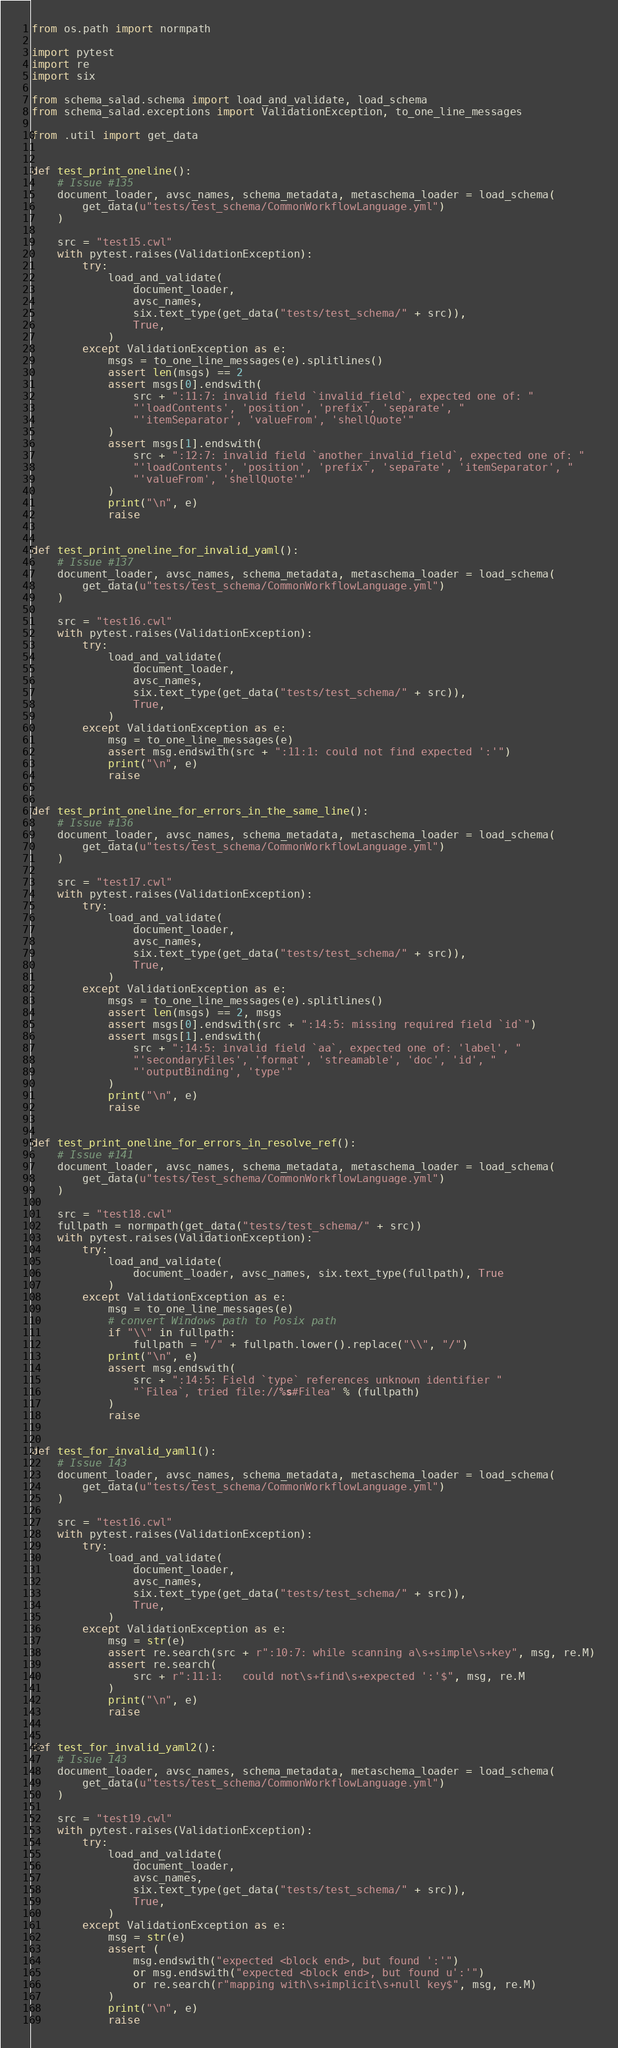<code> <loc_0><loc_0><loc_500><loc_500><_Python_>from os.path import normpath

import pytest
import re
import six

from schema_salad.schema import load_and_validate, load_schema
from schema_salad.exceptions import ValidationException, to_one_line_messages

from .util import get_data


def test_print_oneline():
    # Issue #135
    document_loader, avsc_names, schema_metadata, metaschema_loader = load_schema(
        get_data(u"tests/test_schema/CommonWorkflowLanguage.yml")
    )

    src = "test15.cwl"
    with pytest.raises(ValidationException):
        try:
            load_and_validate(
                document_loader,
                avsc_names,
                six.text_type(get_data("tests/test_schema/" + src)),
                True,
            )
        except ValidationException as e:
            msgs = to_one_line_messages(e).splitlines()
            assert len(msgs) == 2
            assert msgs[0].endswith(
                src + ":11:7: invalid field `invalid_field`, expected one of: "
                "'loadContents', 'position', 'prefix', 'separate', "
                "'itemSeparator', 'valueFrom', 'shellQuote'"
            )
            assert msgs[1].endswith(
                src + ":12:7: invalid field `another_invalid_field`, expected one of: "
                "'loadContents', 'position', 'prefix', 'separate', 'itemSeparator', "
                "'valueFrom', 'shellQuote'"
            )
            print("\n", e)
            raise


def test_print_oneline_for_invalid_yaml():
    # Issue #137
    document_loader, avsc_names, schema_metadata, metaschema_loader = load_schema(
        get_data(u"tests/test_schema/CommonWorkflowLanguage.yml")
    )

    src = "test16.cwl"
    with pytest.raises(ValidationException):
        try:
            load_and_validate(
                document_loader,
                avsc_names,
                six.text_type(get_data("tests/test_schema/" + src)),
                True,
            )
        except ValidationException as e:
            msg = to_one_line_messages(e)
            assert msg.endswith(src + ":11:1: could not find expected ':'")
            print("\n", e)
            raise


def test_print_oneline_for_errors_in_the_same_line():
    # Issue #136
    document_loader, avsc_names, schema_metadata, metaschema_loader = load_schema(
        get_data(u"tests/test_schema/CommonWorkflowLanguage.yml")
    )

    src = "test17.cwl"
    with pytest.raises(ValidationException):
        try:
            load_and_validate(
                document_loader,
                avsc_names,
                six.text_type(get_data("tests/test_schema/" + src)),
                True,
            )
        except ValidationException as e:
            msgs = to_one_line_messages(e).splitlines()
            assert len(msgs) == 2, msgs
            assert msgs[0].endswith(src + ":14:5: missing required field `id`")
            assert msgs[1].endswith(
                src + ":14:5: invalid field `aa`, expected one of: 'label', "
                "'secondaryFiles', 'format', 'streamable', 'doc', 'id', "
                "'outputBinding', 'type'"
            )
            print("\n", e)
            raise


def test_print_oneline_for_errors_in_resolve_ref():
    # Issue #141
    document_loader, avsc_names, schema_metadata, metaschema_loader = load_schema(
        get_data(u"tests/test_schema/CommonWorkflowLanguage.yml")
    )

    src = "test18.cwl"
    fullpath = normpath(get_data("tests/test_schema/" + src))
    with pytest.raises(ValidationException):
        try:
            load_and_validate(
                document_loader, avsc_names, six.text_type(fullpath), True
            )
        except ValidationException as e:
            msg = to_one_line_messages(e)
            # convert Windows path to Posix path
            if "\\" in fullpath:
                fullpath = "/" + fullpath.lower().replace("\\", "/")
            print("\n", e)
            assert msg.endswith(
                src + ":14:5: Field `type` references unknown identifier "
                "`Filea`, tried file://%s#Filea" % (fullpath)
            )
            raise


def test_for_invalid_yaml1():
    # Issue 143
    document_loader, avsc_names, schema_metadata, metaschema_loader = load_schema(
        get_data(u"tests/test_schema/CommonWorkflowLanguage.yml")
    )

    src = "test16.cwl"
    with pytest.raises(ValidationException):
        try:
            load_and_validate(
                document_loader,
                avsc_names,
                six.text_type(get_data("tests/test_schema/" + src)),
                True,
            )
        except ValidationException as e:
            msg = str(e)
            assert re.search(src + r":10:7: while scanning a\s+simple\s+key", msg, re.M)
            assert re.search(
                src + r":11:1:   could not\s+find\s+expected ':'$", msg, re.M
            )
            print("\n", e)
            raise


def test_for_invalid_yaml2():
    # Issue 143
    document_loader, avsc_names, schema_metadata, metaschema_loader = load_schema(
        get_data(u"tests/test_schema/CommonWorkflowLanguage.yml")
    )

    src = "test19.cwl"
    with pytest.raises(ValidationException):
        try:
            load_and_validate(
                document_loader,
                avsc_names,
                six.text_type(get_data("tests/test_schema/" + src)),
                True,
            )
        except ValidationException as e:
            msg = str(e)
            assert (
                msg.endswith("expected <block end>, but found ':'")
                or msg.endswith("expected <block end>, but found u':'")
                or re.search(r"mapping with\s+implicit\s+null key$", msg, re.M)
            )
            print("\n", e)
            raise
</code> 